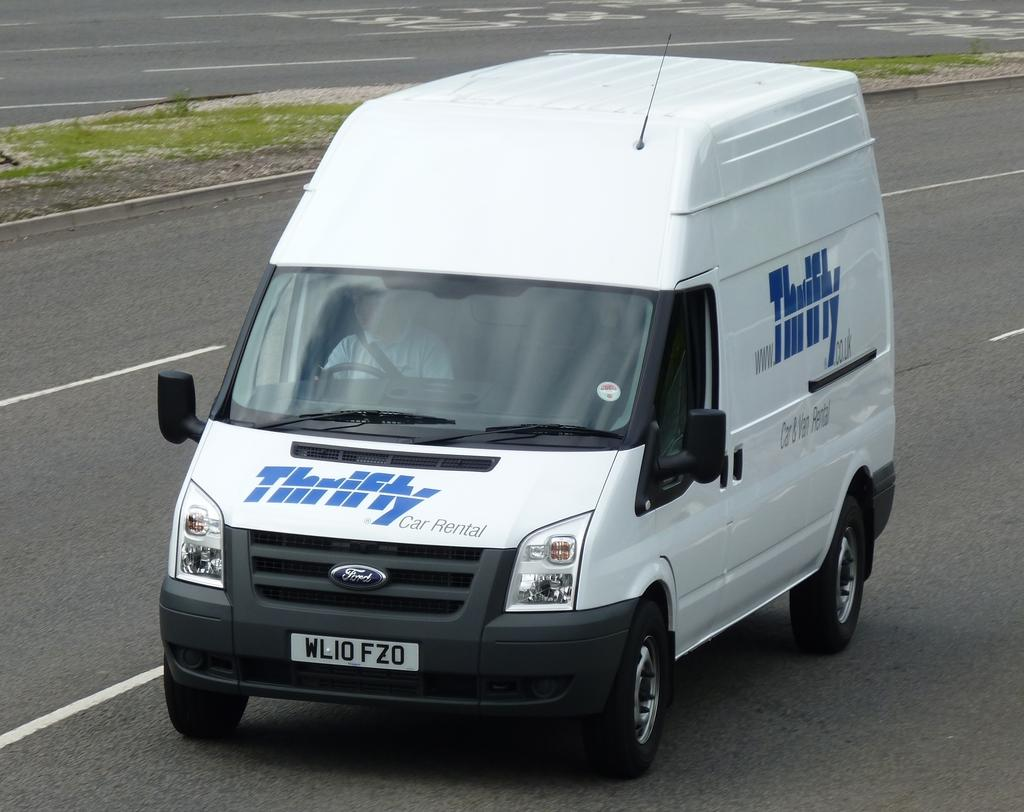<image>
Describe the image concisely. A white van with Thrifty written in blue letters rides down the road 